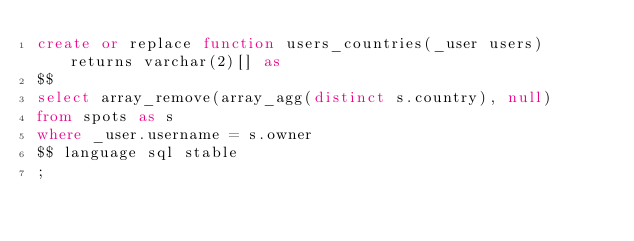<code> <loc_0><loc_0><loc_500><loc_500><_SQL_>create or replace function users_countries(_user users) returns varchar(2)[] as
$$
select array_remove(array_agg(distinct s.country), null)
from spots as s
where _user.username = s.owner
$$ language sql stable
;

</code> 